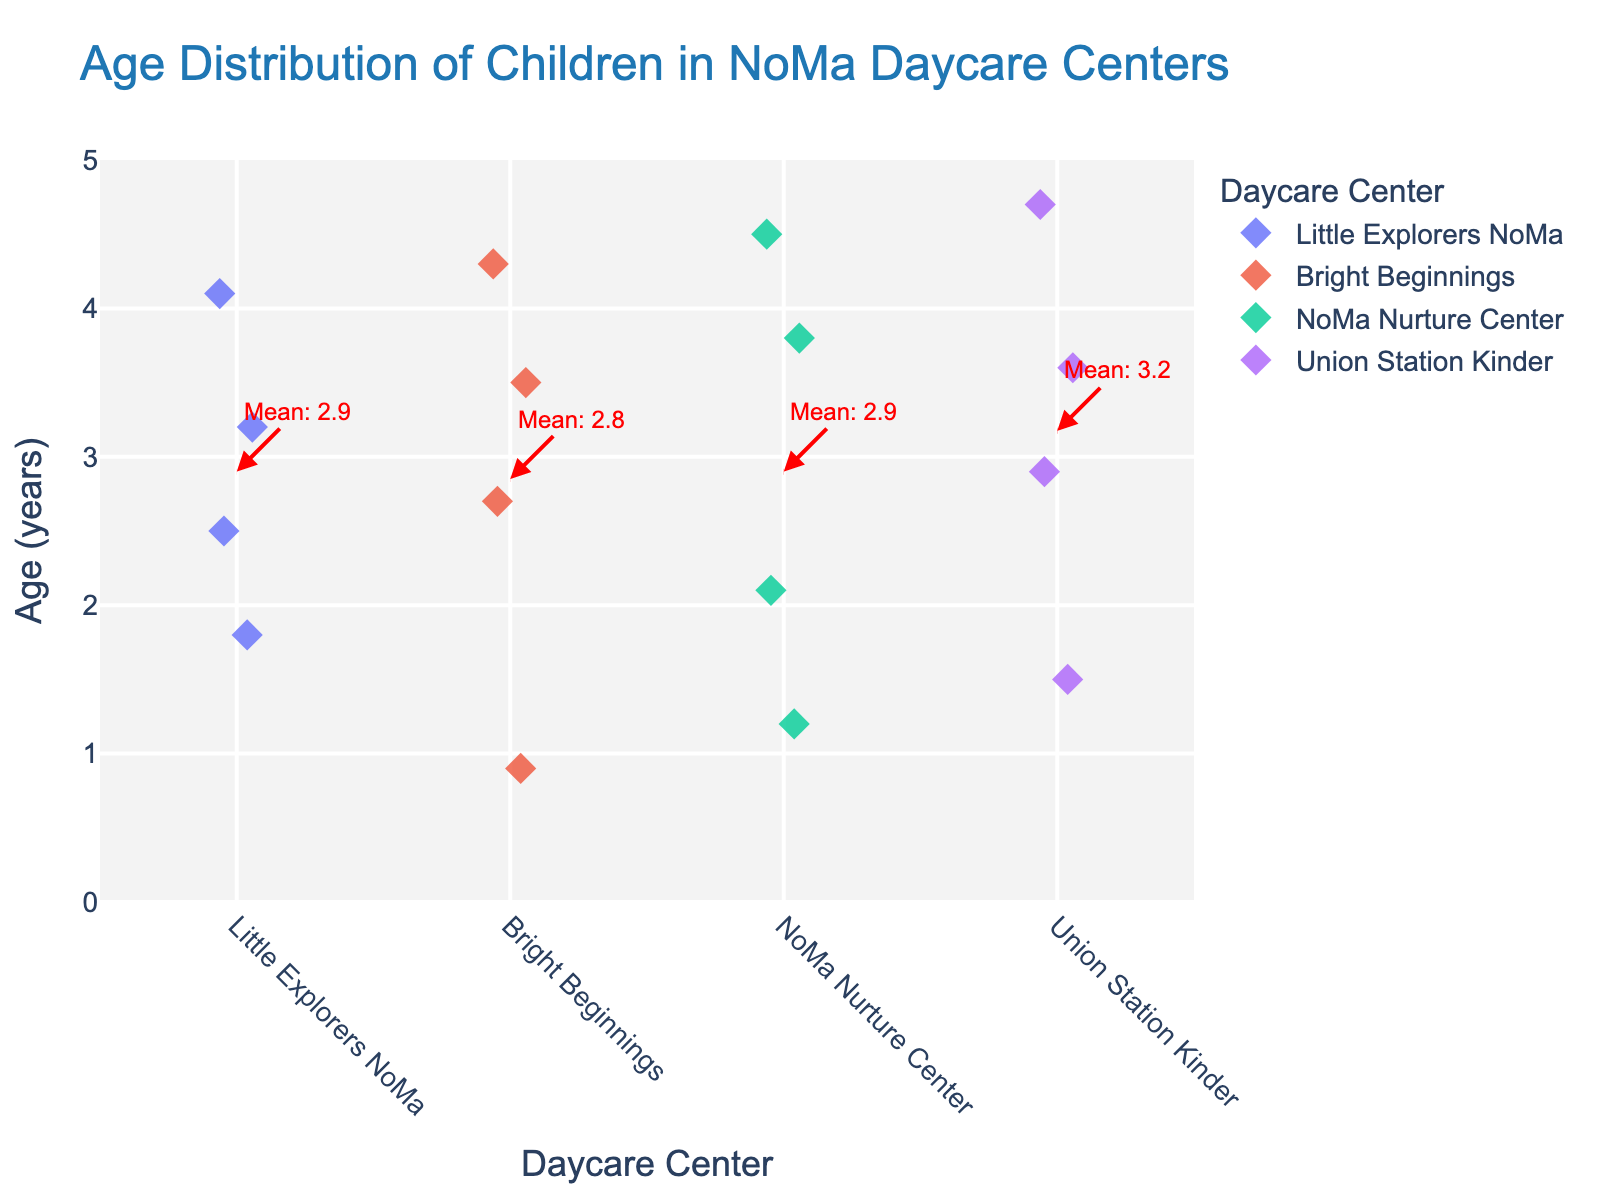Which daycare center has the youngest child? Looking at the figure, we can see that the youngest child is at Bright Beginnings with an age of 0.9 years. This is the lowest point on the y-axis for any daycare.
Answer: Bright Beginnings Which daycare center has the widest range of children's ages? The range is determined by the distance between the youngest and oldest children's ages for each daycare. The widest range is at Union Station Kinder with ages from 1.5 to 4.7 years (a range of 3.2 years).
Answer: Union Station Kinder What is the mean age of children at Little Explorers NoMa? The figure has a red dashed line and an annotation indicating the mean age for each daycare. For Little Explorers NoMa, the mean age annotation reads "Mean: 2.9".
Answer: 2.9 years How many children are there in NoMa Nurture Center? The number of children is represented by the number of points for each daycare. For NoMa Nurture Center, there are 4 points.
Answer: 4 Which daycare has the highest mean age? By comparing the mean age annotations (red dashed lines) in the figure, we see that Union Station Kinder has the highest mean age of 3.2 years.
Answer: Union Station Kinder Is there any daycare where all children are above 2 years old? Examining the plot, we observe that all ages at Union Station Kinder and Little Explorers NoMa are above 2 years.
Answer: Yes, Union Station Kinder and Little Explorers NoMa What is the age range of children at Bright Beginnings? The range is found by subtracting the smallest age from the largest age at Bright Beginnings. The smallest is 0.9 years, and the largest is 4.3 years, thus the range is 4.3 - 0.9 = 3.4 years.
Answer: 3.4 years Which daycare has the most evenly distributed ages? An evenly distributed age range would show less clustering on the plot. Comparing visually, Union Station Kinder shows a relatively even spread from youngest to oldest ages.
Answer: Union Station Kinder How does the mean age at Bright Beginnings compare to the mean age at Little Explorers NoMa? By comparing the mean age annotations, Bright Beginnings has a mean age of 2.85 years, and Little Explorers NoMa has a mean age of 2.9 years, so Bright Beginnings is slightly lower.
Answer: Bright Beginnings is slightly lower than Little Explorers NoMa Do any daycare centers have a mean age above 3 years? Checking the mean age annotations, only Union Station Kinder has a mean age above 3 years, with a mean age of 3.2 years.
Answer: Yes, Union Station Kinder 